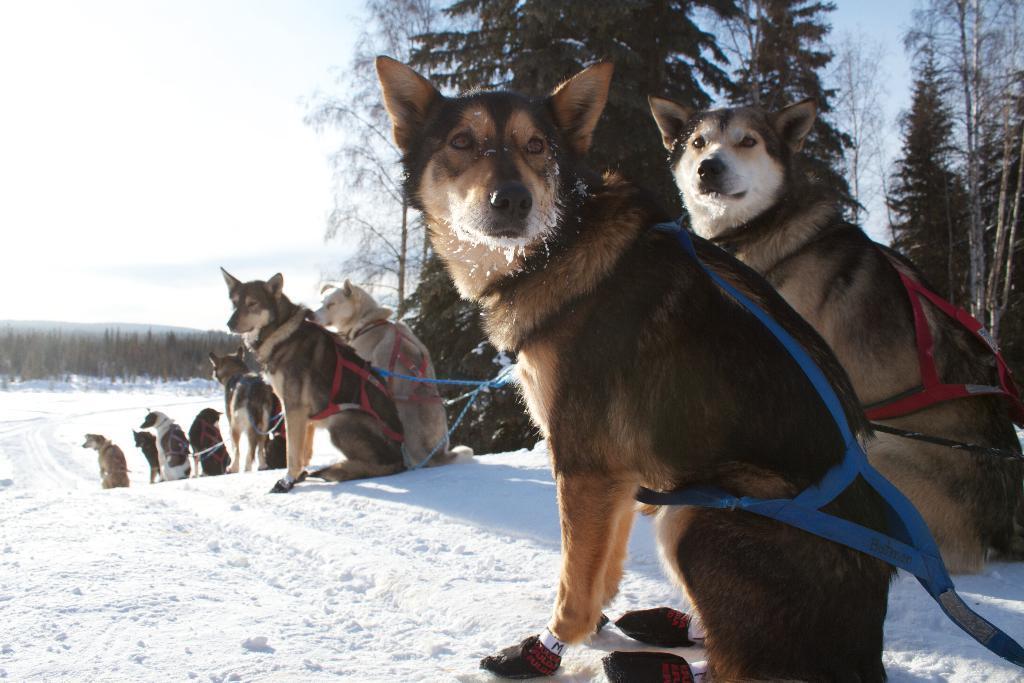How would you summarize this image in a sentence or two? In this image I can see few animals, they are in brown and cream color and they are sitting on the snow. The snow is in white color, background I can see trees in green color and the sky is in white color. 